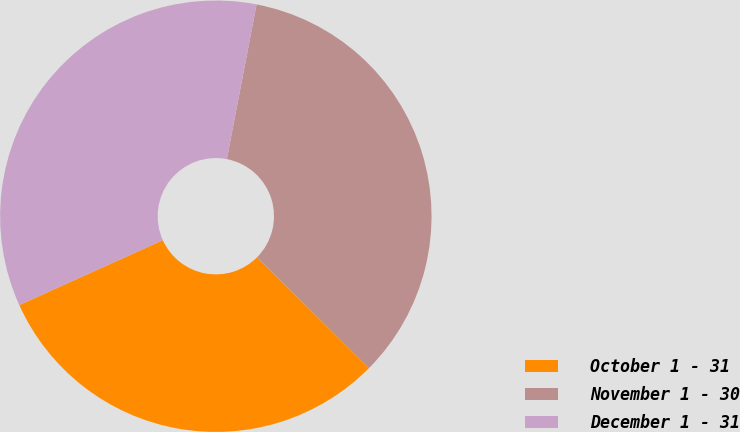Convert chart to OTSL. <chart><loc_0><loc_0><loc_500><loc_500><pie_chart><fcel>October 1 - 31<fcel>November 1 - 30<fcel>December 1 - 31<nl><fcel>30.8%<fcel>34.42%<fcel>34.78%<nl></chart> 